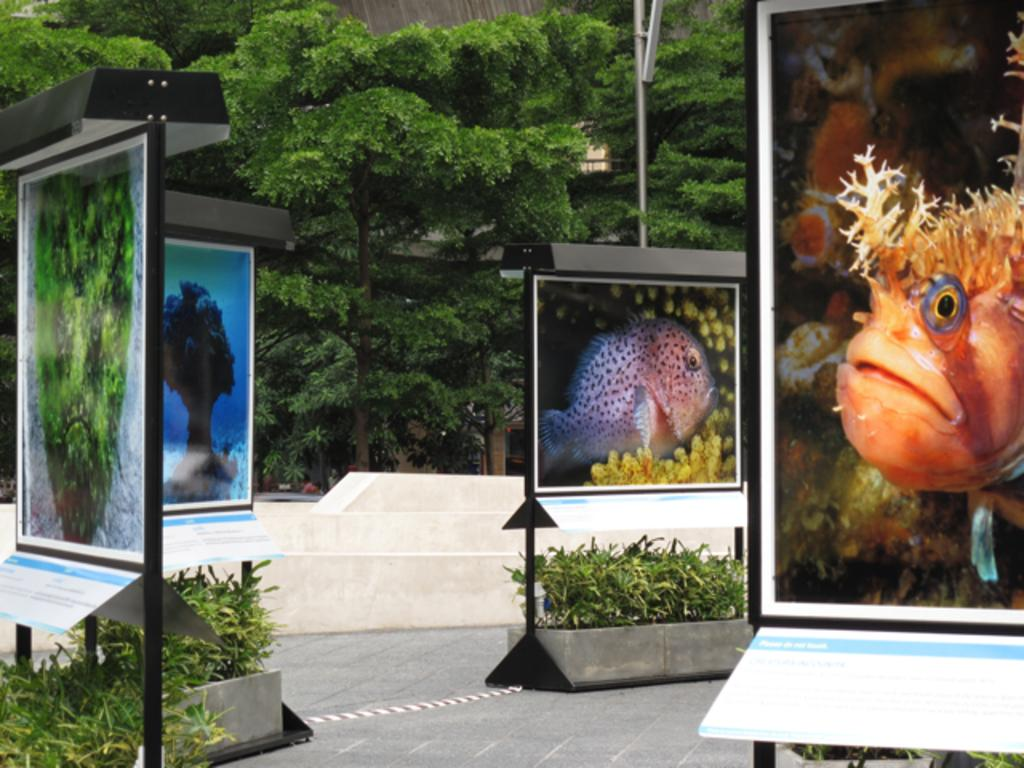What is the main subject of the image? The main subject of the image is boards attached to poles. What is depicted on the boards? Fish and trees are depicted on the boards. What can be seen in the background of the image? There are trees visible in the background of the image. What is the color of the trees in the background? The trees in the background are green. How many chickens are sitting on the sun in the image? There are no chickens or sun present in the image. 